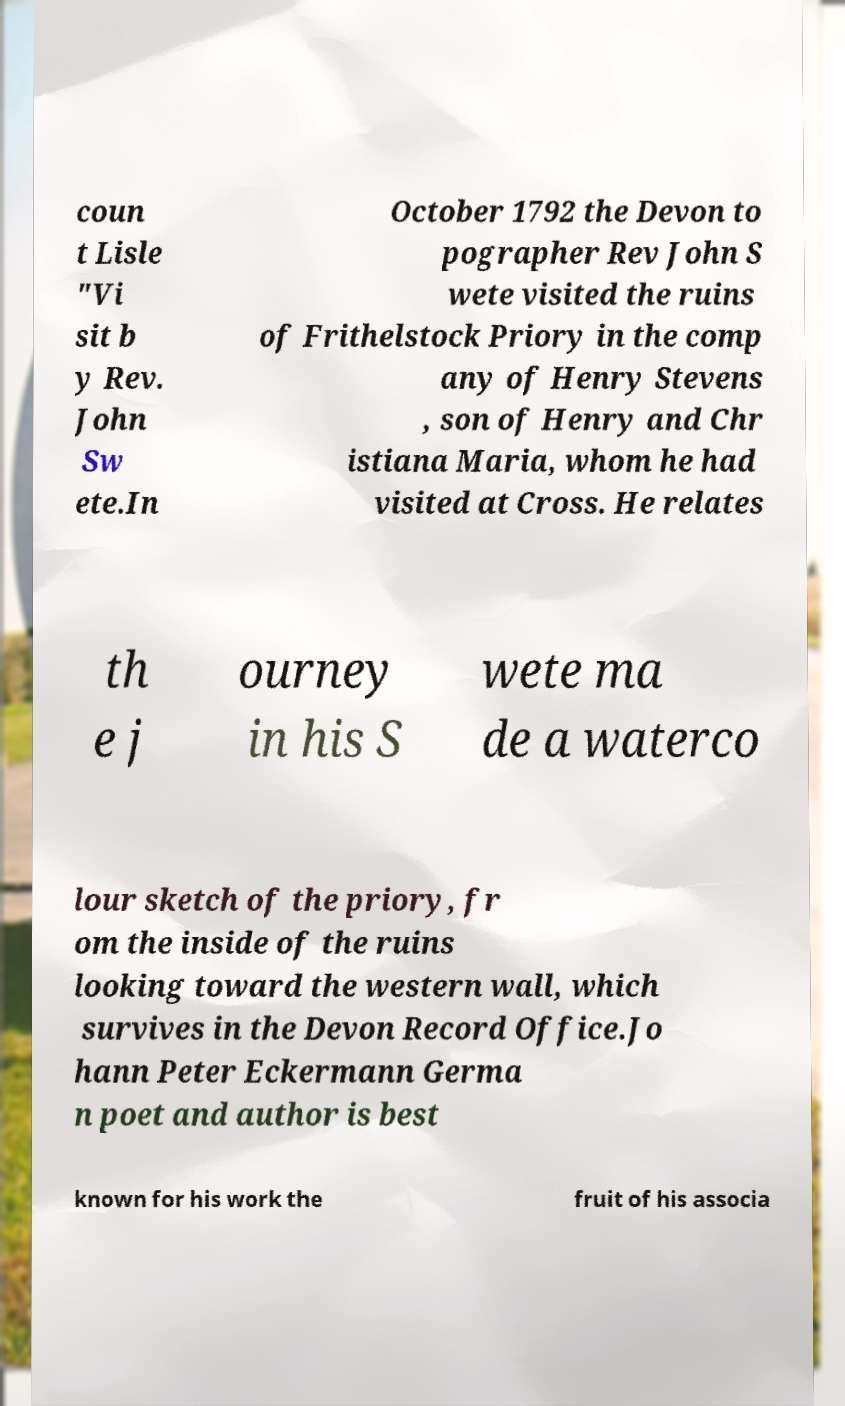For documentation purposes, I need the text within this image transcribed. Could you provide that? coun t Lisle "Vi sit b y Rev. John Sw ete.In October 1792 the Devon to pographer Rev John S wete visited the ruins of Frithelstock Priory in the comp any of Henry Stevens , son of Henry and Chr istiana Maria, whom he had visited at Cross. He relates th e j ourney in his S wete ma de a waterco lour sketch of the priory, fr om the inside of the ruins looking toward the western wall, which survives in the Devon Record Office.Jo hann Peter Eckermann Germa n poet and author is best known for his work the fruit of his associa 